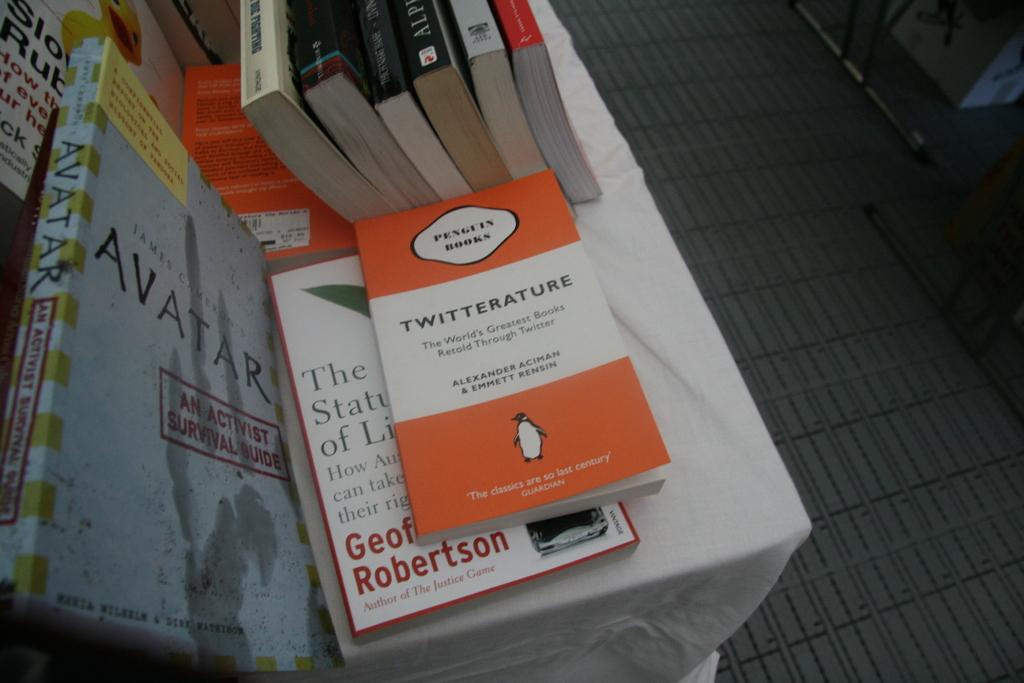Who wrote twitterature?
Your response must be concise. Alexander aciman & emmett rensin. What kind of survival guide is the book on the left?
Provide a short and direct response. Activist. 